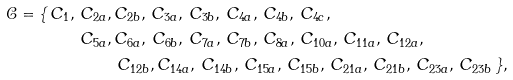Convert formula to latex. <formula><loc_0><loc_0><loc_500><loc_500>\mathcal { C } = \{ \, C _ { 1 } , \, C _ { 2 a } , \, & C _ { 2 b } , \, C _ { 3 a } , \, C _ { 3 b } , \, C _ { 4 a } , \, C _ { 4 b } , \, C _ { 4 c } , \, \\ C _ { 5 a } , \, & C _ { 6 a } , \, C _ { 6 b } , \, C _ { 7 a } , \, C _ { 7 b } , \, C _ { 8 a } , \, C _ { 1 0 a } , \, C _ { 1 1 a } , \, C _ { 1 2 a } , \\ & \, C _ { 1 2 b } , C _ { 1 4 a } , \, C _ { 1 4 b } , \, C _ { 1 5 a } , \, C _ { 1 5 b } , \, C _ { 2 1 a } , \, C _ { 2 1 b } , \, C _ { 2 3 a } , \, C _ { 2 3 b } \, \} ,</formula> 